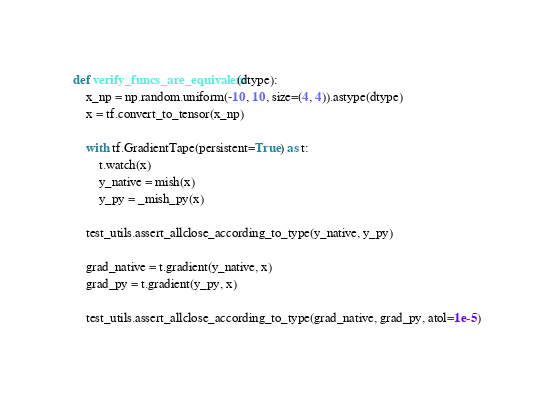<code> <loc_0><loc_0><loc_500><loc_500><_Python_>def verify_funcs_are_equivalent(dtype):
    x_np = np.random.uniform(-10, 10, size=(4, 4)).astype(dtype)
    x = tf.convert_to_tensor(x_np)

    with tf.GradientTape(persistent=True) as t:
        t.watch(x)
        y_native = mish(x)
        y_py = _mish_py(x)

    test_utils.assert_allclose_according_to_type(y_native, y_py)

    grad_native = t.gradient(y_native, x)
    grad_py = t.gradient(y_py, x)

    test_utils.assert_allclose_according_to_type(grad_native, grad_py, atol=1e-5)
</code> 